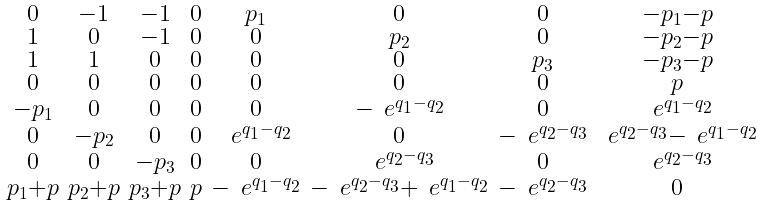Convert formula to latex. <formula><loc_0><loc_0><loc_500><loc_500>\begin{smallmatrix} 0 & - 1 & - 1 & 0 & p _ { 1 } & 0 & 0 & - p _ { 1 } - p \\ 1 & 0 & - 1 & 0 & 0 & p _ { 2 } & 0 & - p _ { 2 } - p \\ 1 & 1 & 0 & 0 & 0 & 0 & p _ { 3 } & - p _ { 3 } - p \\ 0 & 0 & 0 & 0 & 0 & 0 & 0 & p \\ - p _ { 1 } & 0 & 0 & 0 & 0 & - \ e ^ { q _ { 1 } - q _ { 2 } } & 0 & \ e ^ { q _ { 1 } - q _ { 2 } } \\ 0 & - p _ { 2 } & 0 & 0 & \ e ^ { q _ { 1 } - q _ { 2 } } & 0 & - \ e ^ { q _ { 2 } - q _ { 3 } } & \ e ^ { q _ { 2 } - q _ { 3 } } - \ e ^ { q _ { 1 } - q _ { 2 } } \\ 0 & 0 & - p _ { 3 } & 0 & 0 & \ e ^ { q _ { 2 } - q _ { 3 } } & 0 & \ e ^ { q _ { 2 } - q _ { 3 } } \\ p _ { 1 } + p & p _ { 2 } + p & p _ { 3 } + p & p & - \ e ^ { q _ { 1 } - q _ { 2 } } & - \ e ^ { q _ { 2 } - q _ { 3 } } + \ e ^ { q _ { 1 } - q _ { 2 } } & - \ e ^ { q _ { 2 } - q _ { 3 } } & 0 \end{smallmatrix}</formula> 